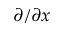<formula> <loc_0><loc_0><loc_500><loc_500>\partial / \partial x</formula> 